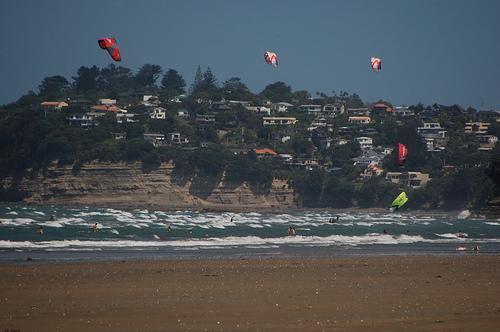How many kites are there?
Give a very brief answer. 5. How many pieces has the pizza been cut into?
Give a very brief answer. 0. 